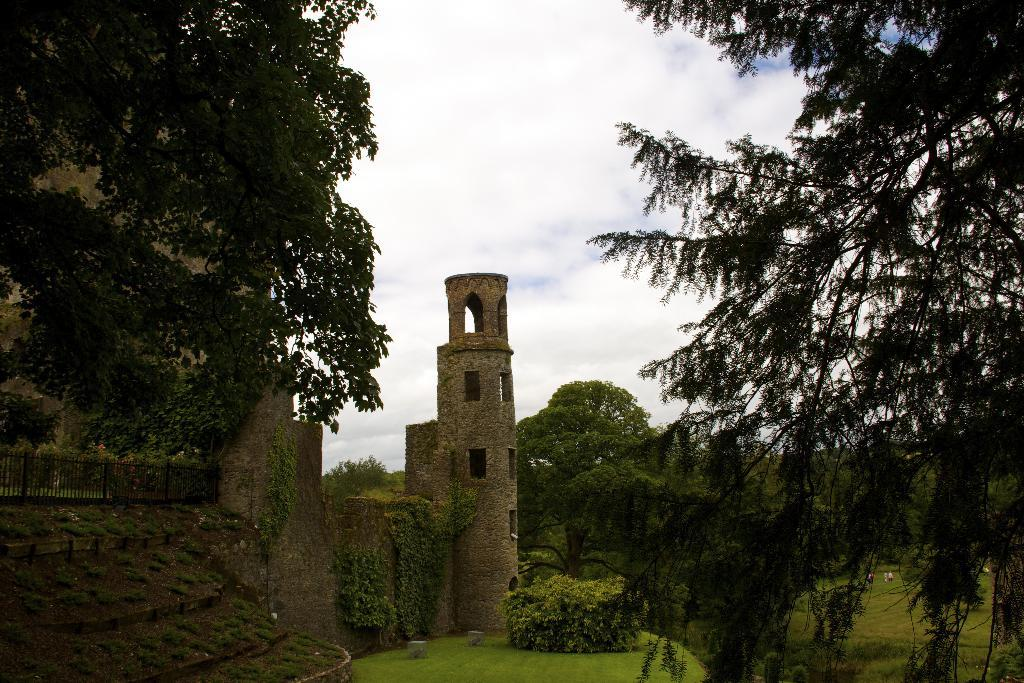What type of structure is present in the image? There is a fort in the image. What type of barrier can be seen in the image? There is a fence in the image. What type of vegetation is present in the image? There is grass and trees in the image. What can be seen in the sky in the image? There are clouds visible in the image. Are there any people visible in the image? Yes, there are people in the background of the image. What type of oatmeal is being served to the people in the image? There is no oatmeal present in the image. How many feet are visible in the image? There is no specific number of feet visible in the image, as it is not focused on people's feet. 